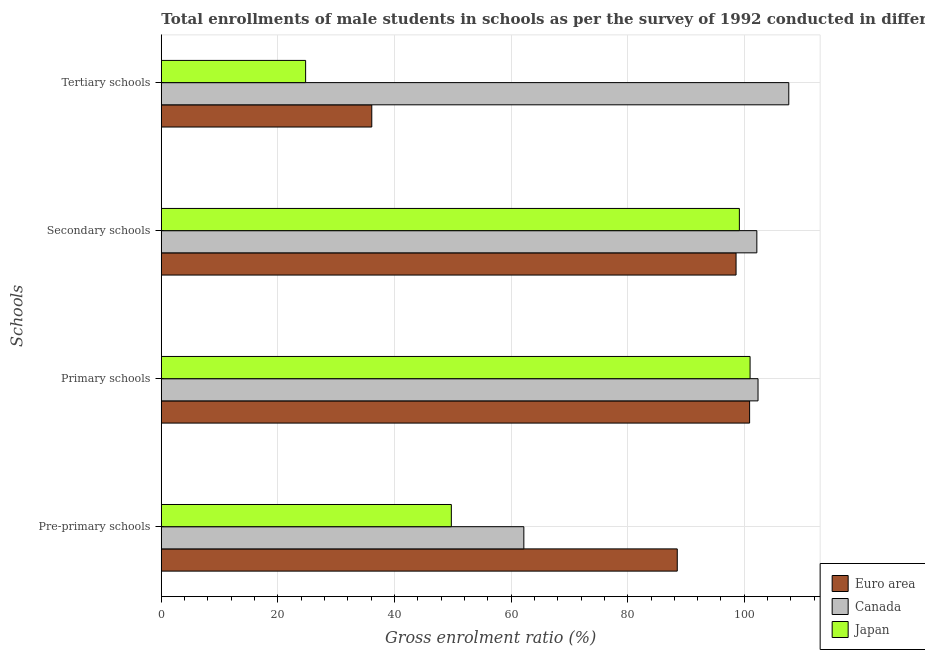How many different coloured bars are there?
Offer a very short reply. 3. What is the label of the 2nd group of bars from the top?
Provide a succinct answer. Secondary schools. What is the gross enrolment ratio(male) in secondary schools in Euro area?
Your answer should be very brief. 98.59. Across all countries, what is the maximum gross enrolment ratio(male) in primary schools?
Give a very brief answer. 102.36. Across all countries, what is the minimum gross enrolment ratio(male) in secondary schools?
Your answer should be compact. 98.59. What is the total gross enrolment ratio(male) in primary schools in the graph?
Ensure brevity in your answer.  304.26. What is the difference between the gross enrolment ratio(male) in primary schools in Euro area and that in Japan?
Keep it short and to the point. -0.08. What is the difference between the gross enrolment ratio(male) in primary schools in Canada and the gross enrolment ratio(male) in pre-primary schools in Japan?
Make the answer very short. 52.61. What is the average gross enrolment ratio(male) in pre-primary schools per country?
Give a very brief answer. 66.81. What is the difference between the gross enrolment ratio(male) in secondary schools and gross enrolment ratio(male) in tertiary schools in Japan?
Ensure brevity in your answer.  74.4. What is the ratio of the gross enrolment ratio(male) in pre-primary schools in Euro area to that in Japan?
Your answer should be compact. 1.78. Is the difference between the gross enrolment ratio(male) in primary schools in Euro area and Japan greater than the difference between the gross enrolment ratio(male) in pre-primary schools in Euro area and Japan?
Provide a succinct answer. No. What is the difference between the highest and the second highest gross enrolment ratio(male) in tertiary schools?
Make the answer very short. 71.53. What is the difference between the highest and the lowest gross enrolment ratio(male) in tertiary schools?
Make the answer very short. 82.88. What does the 1st bar from the top in Primary schools represents?
Ensure brevity in your answer.  Japan. How many bars are there?
Your answer should be very brief. 12. Are all the bars in the graph horizontal?
Your answer should be very brief. Yes. How many countries are there in the graph?
Make the answer very short. 3. Does the graph contain any zero values?
Provide a short and direct response. No. Where does the legend appear in the graph?
Offer a terse response. Bottom right. How are the legend labels stacked?
Keep it short and to the point. Vertical. What is the title of the graph?
Give a very brief answer. Total enrollments of male students in schools as per the survey of 1992 conducted in different countries. Does "St. Lucia" appear as one of the legend labels in the graph?
Provide a succinct answer. No. What is the label or title of the X-axis?
Offer a terse response. Gross enrolment ratio (%). What is the label or title of the Y-axis?
Your answer should be compact. Schools. What is the Gross enrolment ratio (%) in Euro area in Pre-primary schools?
Offer a terse response. 88.5. What is the Gross enrolment ratio (%) of Canada in Pre-primary schools?
Give a very brief answer. 62.19. What is the Gross enrolment ratio (%) in Japan in Pre-primary schools?
Offer a very short reply. 49.75. What is the Gross enrolment ratio (%) in Euro area in Primary schools?
Your answer should be very brief. 100.91. What is the Gross enrolment ratio (%) of Canada in Primary schools?
Your answer should be very brief. 102.36. What is the Gross enrolment ratio (%) in Japan in Primary schools?
Your response must be concise. 100.99. What is the Gross enrolment ratio (%) of Euro area in Secondary schools?
Offer a very short reply. 98.59. What is the Gross enrolment ratio (%) in Canada in Secondary schools?
Your answer should be very brief. 102.15. What is the Gross enrolment ratio (%) in Japan in Secondary schools?
Provide a short and direct response. 99.16. What is the Gross enrolment ratio (%) of Euro area in Tertiary schools?
Give a very brief answer. 36.1. What is the Gross enrolment ratio (%) of Canada in Tertiary schools?
Offer a terse response. 107.63. What is the Gross enrolment ratio (%) in Japan in Tertiary schools?
Your answer should be compact. 24.75. Across all Schools, what is the maximum Gross enrolment ratio (%) in Euro area?
Offer a very short reply. 100.91. Across all Schools, what is the maximum Gross enrolment ratio (%) of Canada?
Offer a very short reply. 107.63. Across all Schools, what is the maximum Gross enrolment ratio (%) of Japan?
Offer a very short reply. 100.99. Across all Schools, what is the minimum Gross enrolment ratio (%) of Euro area?
Make the answer very short. 36.1. Across all Schools, what is the minimum Gross enrolment ratio (%) in Canada?
Make the answer very short. 62.19. Across all Schools, what is the minimum Gross enrolment ratio (%) of Japan?
Keep it short and to the point. 24.75. What is the total Gross enrolment ratio (%) of Euro area in the graph?
Make the answer very short. 324.1. What is the total Gross enrolment ratio (%) in Canada in the graph?
Your response must be concise. 374.32. What is the total Gross enrolment ratio (%) in Japan in the graph?
Your answer should be very brief. 274.65. What is the difference between the Gross enrolment ratio (%) of Euro area in Pre-primary schools and that in Primary schools?
Offer a terse response. -12.41. What is the difference between the Gross enrolment ratio (%) in Canada in Pre-primary schools and that in Primary schools?
Your answer should be very brief. -40.17. What is the difference between the Gross enrolment ratio (%) of Japan in Pre-primary schools and that in Primary schools?
Make the answer very short. -51.24. What is the difference between the Gross enrolment ratio (%) of Euro area in Pre-primary schools and that in Secondary schools?
Offer a very short reply. -10.08. What is the difference between the Gross enrolment ratio (%) of Canada in Pre-primary schools and that in Secondary schools?
Provide a succinct answer. -39.97. What is the difference between the Gross enrolment ratio (%) of Japan in Pre-primary schools and that in Secondary schools?
Your answer should be very brief. -49.41. What is the difference between the Gross enrolment ratio (%) of Euro area in Pre-primary schools and that in Tertiary schools?
Make the answer very short. 52.4. What is the difference between the Gross enrolment ratio (%) in Canada in Pre-primary schools and that in Tertiary schools?
Provide a short and direct response. -45.44. What is the difference between the Gross enrolment ratio (%) in Japan in Pre-primary schools and that in Tertiary schools?
Make the answer very short. 25. What is the difference between the Gross enrolment ratio (%) of Euro area in Primary schools and that in Secondary schools?
Your response must be concise. 2.32. What is the difference between the Gross enrolment ratio (%) in Canada in Primary schools and that in Secondary schools?
Offer a terse response. 0.2. What is the difference between the Gross enrolment ratio (%) of Japan in Primary schools and that in Secondary schools?
Ensure brevity in your answer.  1.83. What is the difference between the Gross enrolment ratio (%) of Euro area in Primary schools and that in Tertiary schools?
Make the answer very short. 64.81. What is the difference between the Gross enrolment ratio (%) in Canada in Primary schools and that in Tertiary schools?
Keep it short and to the point. -5.27. What is the difference between the Gross enrolment ratio (%) in Japan in Primary schools and that in Tertiary schools?
Your answer should be compact. 76.24. What is the difference between the Gross enrolment ratio (%) of Euro area in Secondary schools and that in Tertiary schools?
Provide a succinct answer. 62.48. What is the difference between the Gross enrolment ratio (%) in Canada in Secondary schools and that in Tertiary schools?
Ensure brevity in your answer.  -5.48. What is the difference between the Gross enrolment ratio (%) in Japan in Secondary schools and that in Tertiary schools?
Give a very brief answer. 74.4. What is the difference between the Gross enrolment ratio (%) of Euro area in Pre-primary schools and the Gross enrolment ratio (%) of Canada in Primary schools?
Keep it short and to the point. -13.85. What is the difference between the Gross enrolment ratio (%) in Euro area in Pre-primary schools and the Gross enrolment ratio (%) in Japan in Primary schools?
Offer a very short reply. -12.49. What is the difference between the Gross enrolment ratio (%) of Canada in Pre-primary schools and the Gross enrolment ratio (%) of Japan in Primary schools?
Your answer should be very brief. -38.81. What is the difference between the Gross enrolment ratio (%) of Euro area in Pre-primary schools and the Gross enrolment ratio (%) of Canada in Secondary schools?
Your answer should be very brief. -13.65. What is the difference between the Gross enrolment ratio (%) of Euro area in Pre-primary schools and the Gross enrolment ratio (%) of Japan in Secondary schools?
Your answer should be compact. -10.65. What is the difference between the Gross enrolment ratio (%) in Canada in Pre-primary schools and the Gross enrolment ratio (%) in Japan in Secondary schools?
Your answer should be very brief. -36.97. What is the difference between the Gross enrolment ratio (%) in Euro area in Pre-primary schools and the Gross enrolment ratio (%) in Canada in Tertiary schools?
Your answer should be compact. -19.13. What is the difference between the Gross enrolment ratio (%) of Euro area in Pre-primary schools and the Gross enrolment ratio (%) of Japan in Tertiary schools?
Your answer should be very brief. 63.75. What is the difference between the Gross enrolment ratio (%) in Canada in Pre-primary schools and the Gross enrolment ratio (%) in Japan in Tertiary schools?
Make the answer very short. 37.43. What is the difference between the Gross enrolment ratio (%) in Euro area in Primary schools and the Gross enrolment ratio (%) in Canada in Secondary schools?
Offer a very short reply. -1.24. What is the difference between the Gross enrolment ratio (%) of Euro area in Primary schools and the Gross enrolment ratio (%) of Japan in Secondary schools?
Offer a very short reply. 1.75. What is the difference between the Gross enrolment ratio (%) in Canada in Primary schools and the Gross enrolment ratio (%) in Japan in Secondary schools?
Ensure brevity in your answer.  3.2. What is the difference between the Gross enrolment ratio (%) of Euro area in Primary schools and the Gross enrolment ratio (%) of Canada in Tertiary schools?
Offer a very short reply. -6.72. What is the difference between the Gross enrolment ratio (%) in Euro area in Primary schools and the Gross enrolment ratio (%) in Japan in Tertiary schools?
Keep it short and to the point. 76.16. What is the difference between the Gross enrolment ratio (%) of Canada in Primary schools and the Gross enrolment ratio (%) of Japan in Tertiary schools?
Offer a terse response. 77.6. What is the difference between the Gross enrolment ratio (%) of Euro area in Secondary schools and the Gross enrolment ratio (%) of Canada in Tertiary schools?
Provide a succinct answer. -9.04. What is the difference between the Gross enrolment ratio (%) in Euro area in Secondary schools and the Gross enrolment ratio (%) in Japan in Tertiary schools?
Your answer should be compact. 73.83. What is the difference between the Gross enrolment ratio (%) of Canada in Secondary schools and the Gross enrolment ratio (%) of Japan in Tertiary schools?
Your response must be concise. 77.4. What is the average Gross enrolment ratio (%) of Euro area per Schools?
Provide a succinct answer. 81.03. What is the average Gross enrolment ratio (%) in Canada per Schools?
Ensure brevity in your answer.  93.58. What is the average Gross enrolment ratio (%) in Japan per Schools?
Provide a short and direct response. 68.66. What is the difference between the Gross enrolment ratio (%) in Euro area and Gross enrolment ratio (%) in Canada in Pre-primary schools?
Provide a short and direct response. 26.32. What is the difference between the Gross enrolment ratio (%) of Euro area and Gross enrolment ratio (%) of Japan in Pre-primary schools?
Offer a very short reply. 38.75. What is the difference between the Gross enrolment ratio (%) of Canada and Gross enrolment ratio (%) of Japan in Pre-primary schools?
Make the answer very short. 12.44. What is the difference between the Gross enrolment ratio (%) in Euro area and Gross enrolment ratio (%) in Canada in Primary schools?
Your answer should be very brief. -1.45. What is the difference between the Gross enrolment ratio (%) in Euro area and Gross enrolment ratio (%) in Japan in Primary schools?
Provide a short and direct response. -0.08. What is the difference between the Gross enrolment ratio (%) of Canada and Gross enrolment ratio (%) of Japan in Primary schools?
Offer a very short reply. 1.37. What is the difference between the Gross enrolment ratio (%) of Euro area and Gross enrolment ratio (%) of Canada in Secondary schools?
Offer a very short reply. -3.57. What is the difference between the Gross enrolment ratio (%) of Euro area and Gross enrolment ratio (%) of Japan in Secondary schools?
Your answer should be compact. -0.57. What is the difference between the Gross enrolment ratio (%) of Canada and Gross enrolment ratio (%) of Japan in Secondary schools?
Offer a terse response. 3. What is the difference between the Gross enrolment ratio (%) in Euro area and Gross enrolment ratio (%) in Canada in Tertiary schools?
Your response must be concise. -71.53. What is the difference between the Gross enrolment ratio (%) in Euro area and Gross enrolment ratio (%) in Japan in Tertiary schools?
Your answer should be compact. 11.35. What is the difference between the Gross enrolment ratio (%) of Canada and Gross enrolment ratio (%) of Japan in Tertiary schools?
Give a very brief answer. 82.88. What is the ratio of the Gross enrolment ratio (%) in Euro area in Pre-primary schools to that in Primary schools?
Provide a succinct answer. 0.88. What is the ratio of the Gross enrolment ratio (%) of Canada in Pre-primary schools to that in Primary schools?
Give a very brief answer. 0.61. What is the ratio of the Gross enrolment ratio (%) of Japan in Pre-primary schools to that in Primary schools?
Your response must be concise. 0.49. What is the ratio of the Gross enrolment ratio (%) in Euro area in Pre-primary schools to that in Secondary schools?
Make the answer very short. 0.9. What is the ratio of the Gross enrolment ratio (%) in Canada in Pre-primary schools to that in Secondary schools?
Your response must be concise. 0.61. What is the ratio of the Gross enrolment ratio (%) in Japan in Pre-primary schools to that in Secondary schools?
Give a very brief answer. 0.5. What is the ratio of the Gross enrolment ratio (%) of Euro area in Pre-primary schools to that in Tertiary schools?
Your response must be concise. 2.45. What is the ratio of the Gross enrolment ratio (%) of Canada in Pre-primary schools to that in Tertiary schools?
Offer a terse response. 0.58. What is the ratio of the Gross enrolment ratio (%) in Japan in Pre-primary schools to that in Tertiary schools?
Provide a succinct answer. 2.01. What is the ratio of the Gross enrolment ratio (%) of Euro area in Primary schools to that in Secondary schools?
Offer a terse response. 1.02. What is the ratio of the Gross enrolment ratio (%) in Japan in Primary schools to that in Secondary schools?
Make the answer very short. 1.02. What is the ratio of the Gross enrolment ratio (%) in Euro area in Primary schools to that in Tertiary schools?
Make the answer very short. 2.8. What is the ratio of the Gross enrolment ratio (%) in Canada in Primary schools to that in Tertiary schools?
Make the answer very short. 0.95. What is the ratio of the Gross enrolment ratio (%) of Japan in Primary schools to that in Tertiary schools?
Ensure brevity in your answer.  4.08. What is the ratio of the Gross enrolment ratio (%) of Euro area in Secondary schools to that in Tertiary schools?
Ensure brevity in your answer.  2.73. What is the ratio of the Gross enrolment ratio (%) in Canada in Secondary schools to that in Tertiary schools?
Give a very brief answer. 0.95. What is the ratio of the Gross enrolment ratio (%) in Japan in Secondary schools to that in Tertiary schools?
Your answer should be compact. 4.01. What is the difference between the highest and the second highest Gross enrolment ratio (%) of Euro area?
Give a very brief answer. 2.32. What is the difference between the highest and the second highest Gross enrolment ratio (%) in Canada?
Your response must be concise. 5.27. What is the difference between the highest and the second highest Gross enrolment ratio (%) in Japan?
Provide a short and direct response. 1.83. What is the difference between the highest and the lowest Gross enrolment ratio (%) in Euro area?
Offer a very short reply. 64.81. What is the difference between the highest and the lowest Gross enrolment ratio (%) in Canada?
Make the answer very short. 45.44. What is the difference between the highest and the lowest Gross enrolment ratio (%) in Japan?
Make the answer very short. 76.24. 